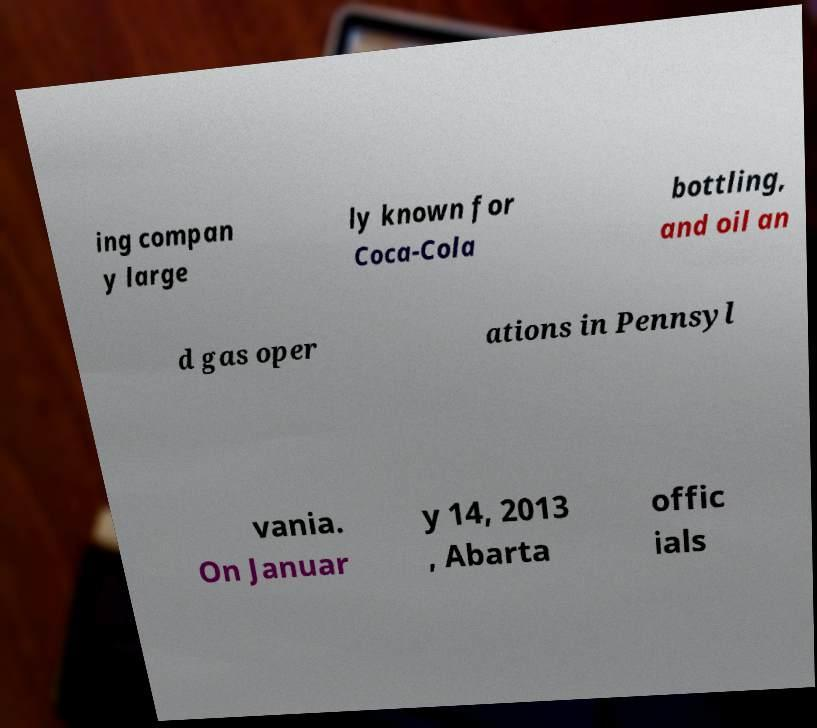Please identify and transcribe the text found in this image. ing compan y large ly known for Coca-Cola bottling, and oil an d gas oper ations in Pennsyl vania. On Januar y 14, 2013 , Abarta offic ials 